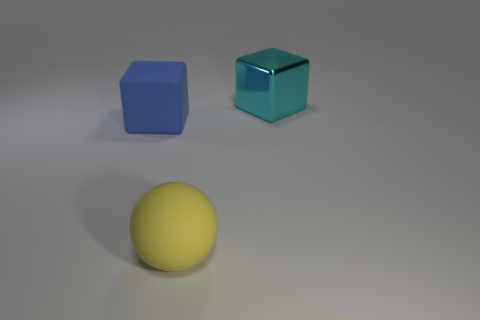Are there more large shiny blocks in front of the rubber cube than large matte spheres that are in front of the cyan object?
Offer a very short reply. No. The metal cube that is the same size as the matte block is what color?
Provide a short and direct response. Cyan. Is there a large thing of the same color as the sphere?
Your response must be concise. No. There is a big object right of the big sphere; is its color the same as the large cube to the left of the large yellow matte thing?
Make the answer very short. No. What is the big block in front of the cyan shiny object made of?
Your response must be concise. Rubber. What is the color of the big thing that is made of the same material as the big ball?
Give a very brief answer. Blue. How many cyan cubes are the same size as the yellow thing?
Your answer should be very brief. 1. Is the size of the matte object to the left of the ball the same as the cyan metallic thing?
Provide a short and direct response. Yes. There is a object that is both in front of the cyan block and right of the matte cube; what is its shape?
Ensure brevity in your answer.  Sphere. Are there any cyan metal blocks on the left side of the big yellow thing?
Keep it short and to the point. No. 